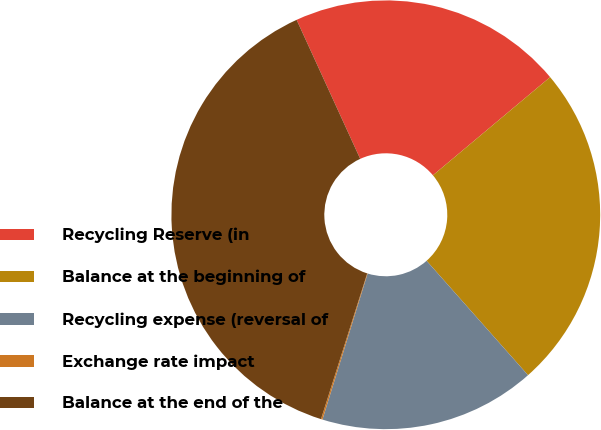Convert chart to OTSL. <chart><loc_0><loc_0><loc_500><loc_500><pie_chart><fcel>Recycling Reserve (in<fcel>Balance at the beginning of<fcel>Recycling expense (reversal of<fcel>Exchange rate impact<fcel>Balance at the end of the<nl><fcel>20.73%<fcel>24.55%<fcel>16.32%<fcel>0.11%<fcel>38.28%<nl></chart> 